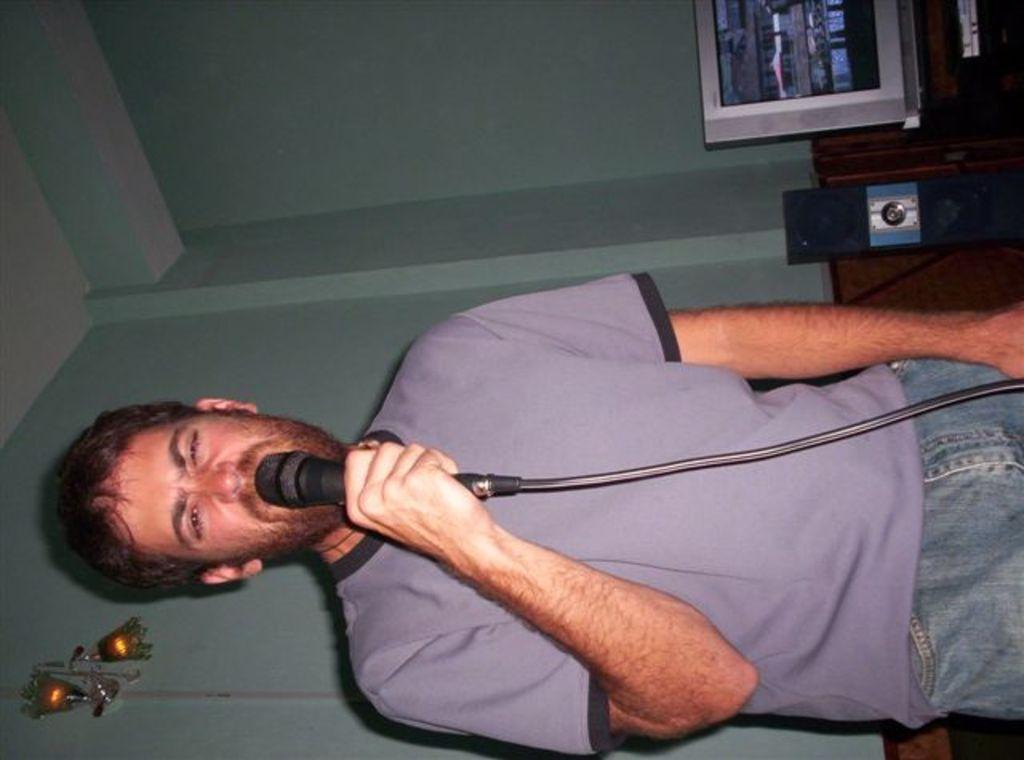What is the main subject of the image? There is a person in the image. What is the person wearing? The person is wearing a purple shirt. What is the person holding? The person is holding a mic. What can be seen in the background of the image? There are lights, a television, and speakers in the background of the image. What type of joke is the person telling in the image? There is no indication in the image that the person is telling a joke, as they are holding a mic, which suggests they might be performing or speaking. 